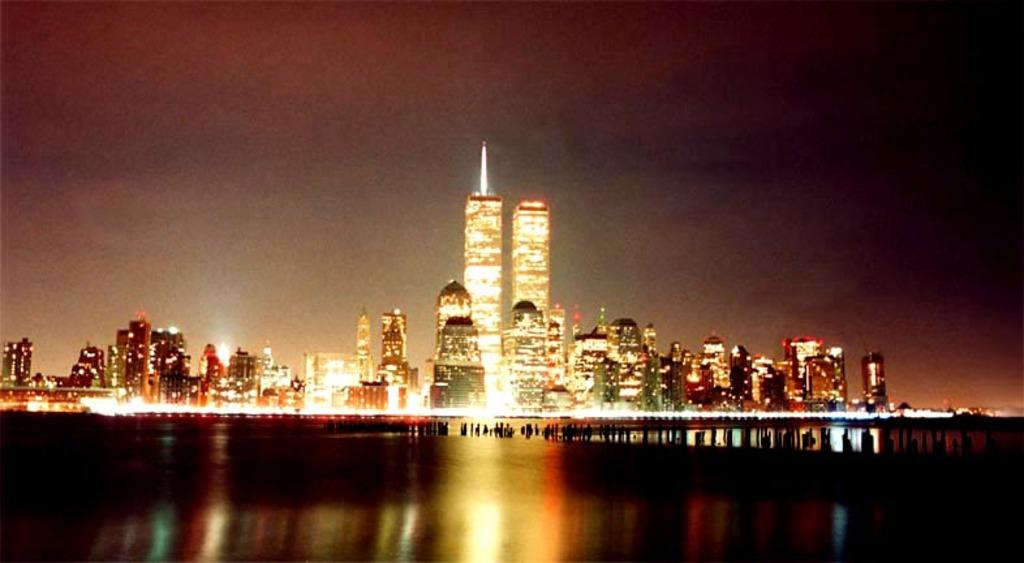What can be observed at the bottom of the image? The bottom of the image is dark. What type of structures can be seen in the image? There are buildings visible in the image. What illuminates the scene in the image? There are lights in the image. What part of the natural environment is visible in the image? The sky is visible in the background of the image. Can you see the tail of the animal in the image? There is no animal present in the image, and therefore no tail can be seen. What does the mouth of the person in the image look like? There is no person present in the image, and therefore no mouth can be described. 